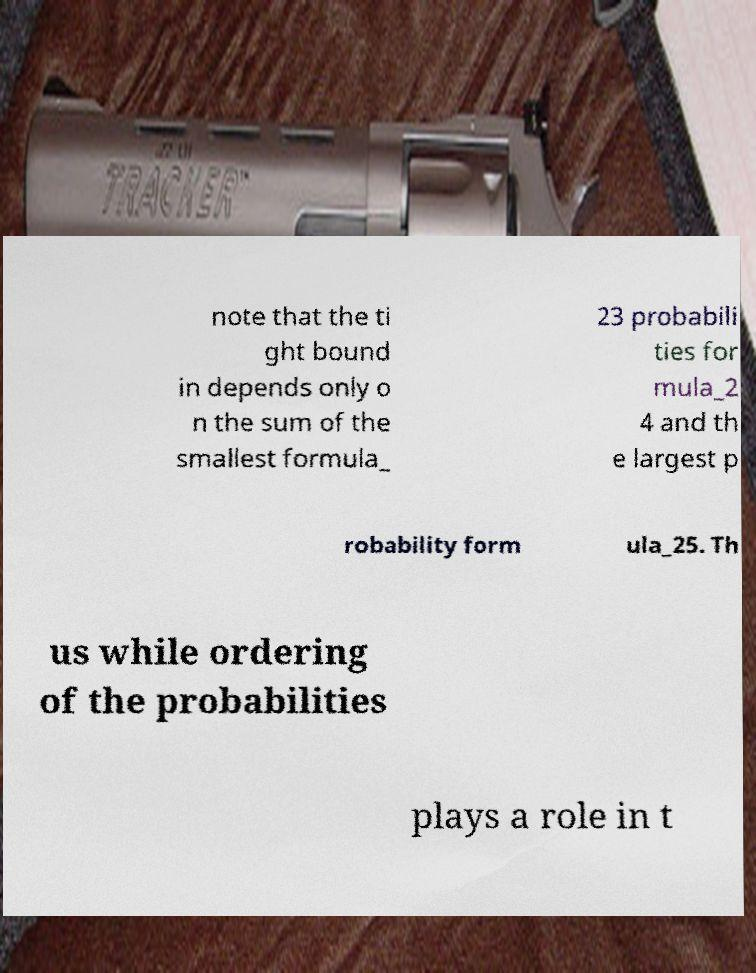I need the written content from this picture converted into text. Can you do that? note that the ti ght bound in depends only o n the sum of the smallest formula_ 23 probabili ties for mula_2 4 and th e largest p robability form ula_25. Th us while ordering of the probabilities plays a role in t 